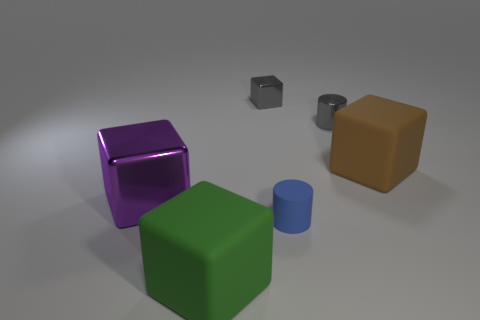Subtract all gray cubes. How many cubes are left? 3 Add 3 big metal objects. How many objects exist? 9 Subtract all yellow cubes. Subtract all blue cylinders. How many cubes are left? 4 Subtract all cubes. How many objects are left? 2 Add 4 small matte cylinders. How many small matte cylinders are left? 5 Add 1 red balls. How many red balls exist? 1 Subtract 0 red cylinders. How many objects are left? 6 Subtract all small cubes. Subtract all brown rubber cubes. How many objects are left? 4 